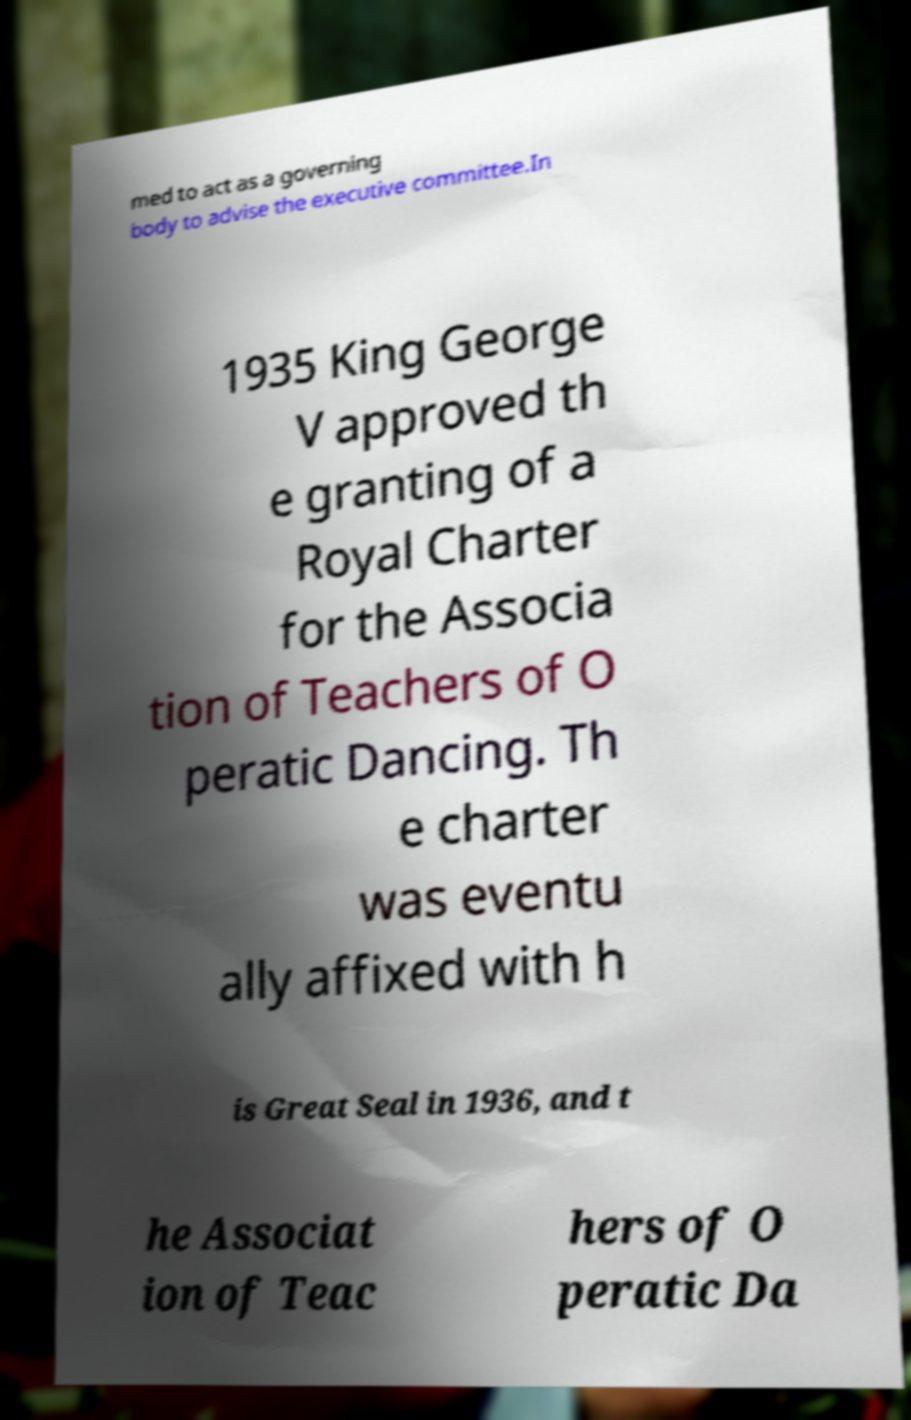Can you accurately transcribe the text from the provided image for me? med to act as a governing body to advise the executive committee.In 1935 King George V approved th e granting of a Royal Charter for the Associa tion of Teachers of O peratic Dancing. Th e charter was eventu ally affixed with h is Great Seal in 1936, and t he Associat ion of Teac hers of O peratic Da 